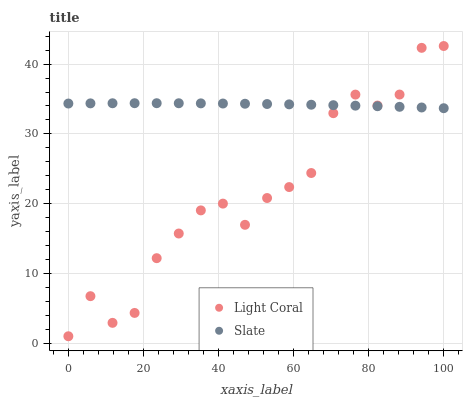Does Light Coral have the minimum area under the curve?
Answer yes or no. Yes. Does Slate have the maximum area under the curve?
Answer yes or no. Yes. Does Slate have the minimum area under the curve?
Answer yes or no. No. Is Slate the smoothest?
Answer yes or no. Yes. Is Light Coral the roughest?
Answer yes or no. Yes. Is Slate the roughest?
Answer yes or no. No. Does Light Coral have the lowest value?
Answer yes or no. Yes. Does Slate have the lowest value?
Answer yes or no. No. Does Light Coral have the highest value?
Answer yes or no. Yes. Does Slate have the highest value?
Answer yes or no. No. Does Light Coral intersect Slate?
Answer yes or no. Yes. Is Light Coral less than Slate?
Answer yes or no. No. Is Light Coral greater than Slate?
Answer yes or no. No. 